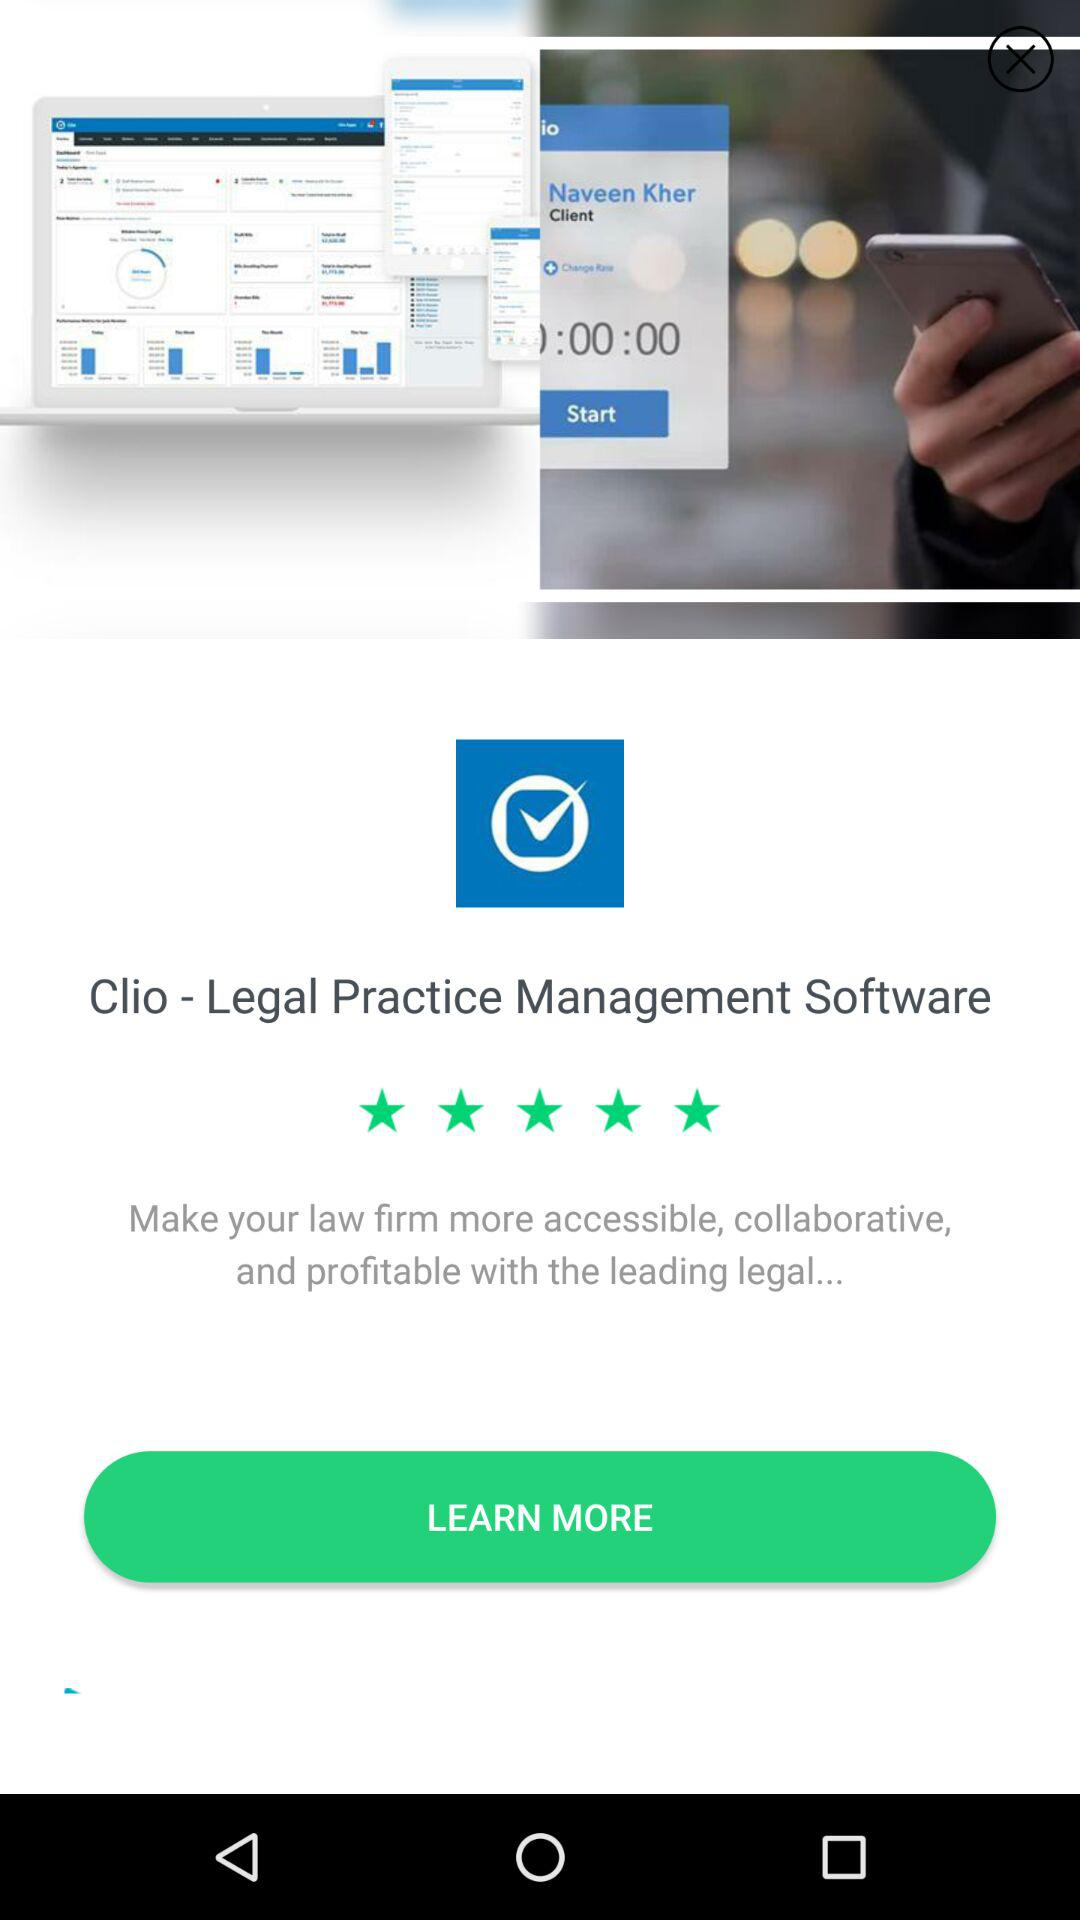What is the star rating for "Clio - Legal Practice Management Software"? The rating is 5 stars. 